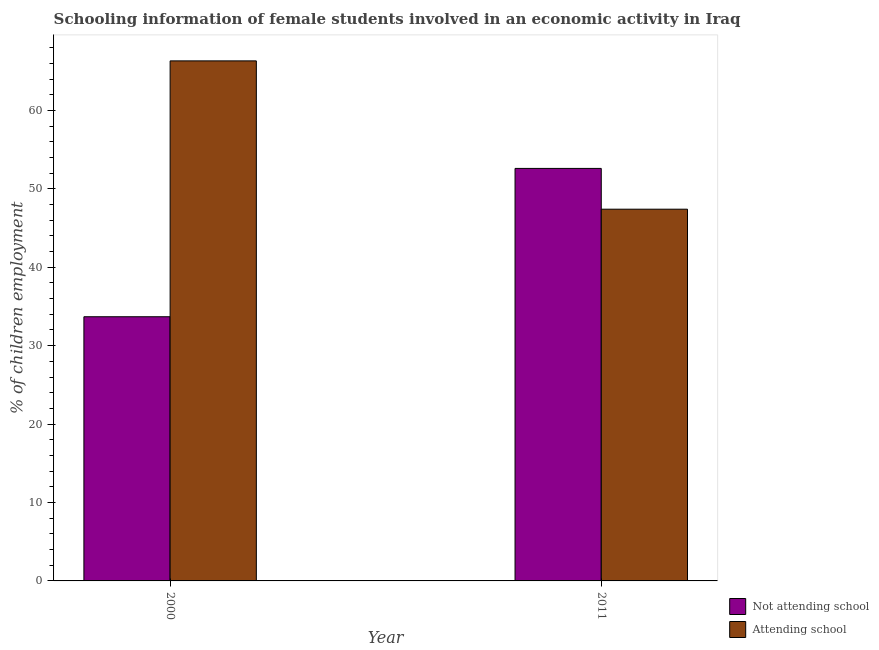How many groups of bars are there?
Offer a terse response. 2. Are the number of bars on each tick of the X-axis equal?
Provide a succinct answer. Yes. How many bars are there on the 1st tick from the right?
Make the answer very short. 2. What is the label of the 1st group of bars from the left?
Your answer should be very brief. 2000. What is the percentage of employed females who are attending school in 2011?
Ensure brevity in your answer.  47.4. Across all years, what is the maximum percentage of employed females who are not attending school?
Your answer should be compact. 52.6. Across all years, what is the minimum percentage of employed females who are not attending school?
Provide a succinct answer. 33.69. What is the total percentage of employed females who are not attending school in the graph?
Provide a short and direct response. 86.29. What is the difference between the percentage of employed females who are not attending school in 2000 and that in 2011?
Offer a terse response. -18.91. What is the difference between the percentage of employed females who are not attending school in 2011 and the percentage of employed females who are attending school in 2000?
Offer a terse response. 18.91. What is the average percentage of employed females who are attending school per year?
Your answer should be compact. 56.86. In the year 2000, what is the difference between the percentage of employed females who are attending school and percentage of employed females who are not attending school?
Ensure brevity in your answer.  0. In how many years, is the percentage of employed females who are attending school greater than 58 %?
Provide a short and direct response. 1. What is the ratio of the percentage of employed females who are not attending school in 2000 to that in 2011?
Ensure brevity in your answer.  0.64. Is the percentage of employed females who are attending school in 2000 less than that in 2011?
Offer a very short reply. No. In how many years, is the percentage of employed females who are attending school greater than the average percentage of employed females who are attending school taken over all years?
Offer a terse response. 1. What does the 2nd bar from the left in 2011 represents?
Your response must be concise. Attending school. What does the 1st bar from the right in 2011 represents?
Give a very brief answer. Attending school. How many years are there in the graph?
Make the answer very short. 2. What is the difference between two consecutive major ticks on the Y-axis?
Give a very brief answer. 10. Does the graph contain grids?
Your answer should be very brief. No. How many legend labels are there?
Offer a terse response. 2. What is the title of the graph?
Your response must be concise. Schooling information of female students involved in an economic activity in Iraq. Does "Unregistered firms" appear as one of the legend labels in the graph?
Give a very brief answer. No. What is the label or title of the Y-axis?
Offer a terse response. % of children employment. What is the % of children employment in Not attending school in 2000?
Give a very brief answer. 33.69. What is the % of children employment of Attending school in 2000?
Ensure brevity in your answer.  66.31. What is the % of children employment in Not attending school in 2011?
Your response must be concise. 52.6. What is the % of children employment of Attending school in 2011?
Make the answer very short. 47.4. Across all years, what is the maximum % of children employment of Not attending school?
Keep it short and to the point. 52.6. Across all years, what is the maximum % of children employment in Attending school?
Ensure brevity in your answer.  66.31. Across all years, what is the minimum % of children employment of Not attending school?
Provide a short and direct response. 33.69. Across all years, what is the minimum % of children employment of Attending school?
Provide a short and direct response. 47.4. What is the total % of children employment in Not attending school in the graph?
Ensure brevity in your answer.  86.29. What is the total % of children employment in Attending school in the graph?
Your answer should be compact. 113.71. What is the difference between the % of children employment in Not attending school in 2000 and that in 2011?
Your answer should be very brief. -18.91. What is the difference between the % of children employment of Attending school in 2000 and that in 2011?
Offer a terse response. 18.91. What is the difference between the % of children employment of Not attending school in 2000 and the % of children employment of Attending school in 2011?
Offer a terse response. -13.71. What is the average % of children employment in Not attending school per year?
Ensure brevity in your answer.  43.14. What is the average % of children employment of Attending school per year?
Provide a succinct answer. 56.86. In the year 2000, what is the difference between the % of children employment in Not attending school and % of children employment in Attending school?
Offer a terse response. -32.63. In the year 2011, what is the difference between the % of children employment in Not attending school and % of children employment in Attending school?
Your answer should be compact. 5.2. What is the ratio of the % of children employment in Not attending school in 2000 to that in 2011?
Your answer should be compact. 0.64. What is the ratio of the % of children employment of Attending school in 2000 to that in 2011?
Your answer should be compact. 1.4. What is the difference between the highest and the second highest % of children employment of Not attending school?
Your answer should be very brief. 18.91. What is the difference between the highest and the second highest % of children employment of Attending school?
Offer a very short reply. 18.91. What is the difference between the highest and the lowest % of children employment of Not attending school?
Give a very brief answer. 18.91. What is the difference between the highest and the lowest % of children employment in Attending school?
Keep it short and to the point. 18.91. 